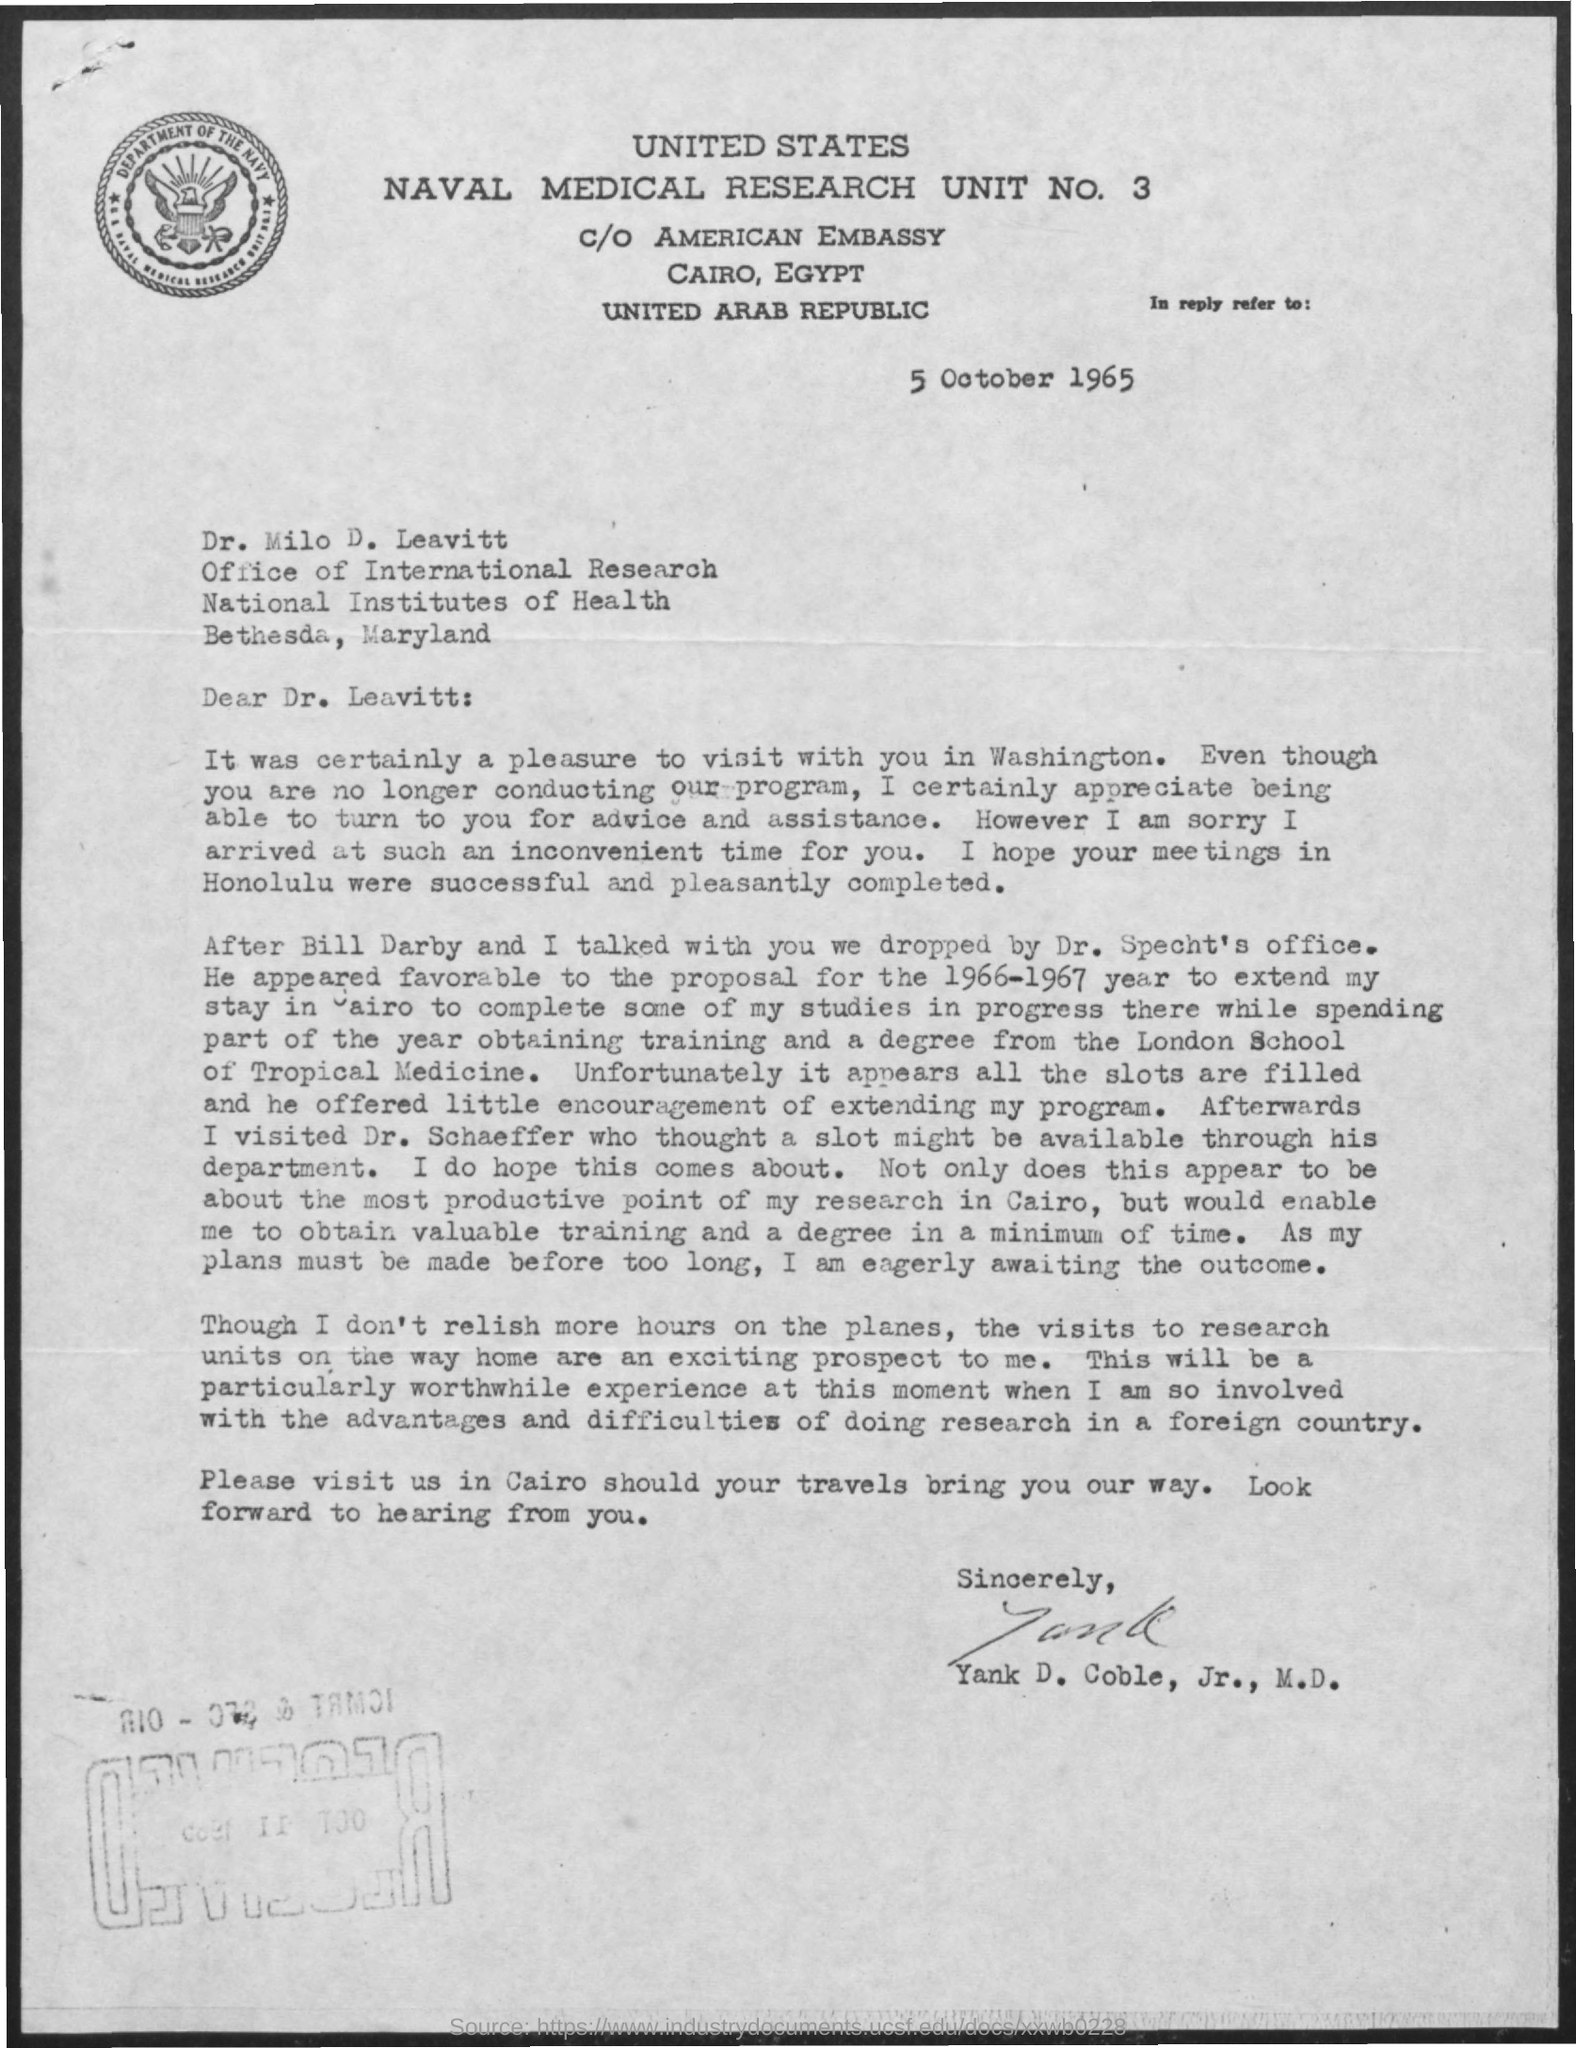What is the date mentioned ?
Provide a succinct answer. 5 October 1965. To whom this letter is written
Offer a very short reply. Dr. Leavitt. 